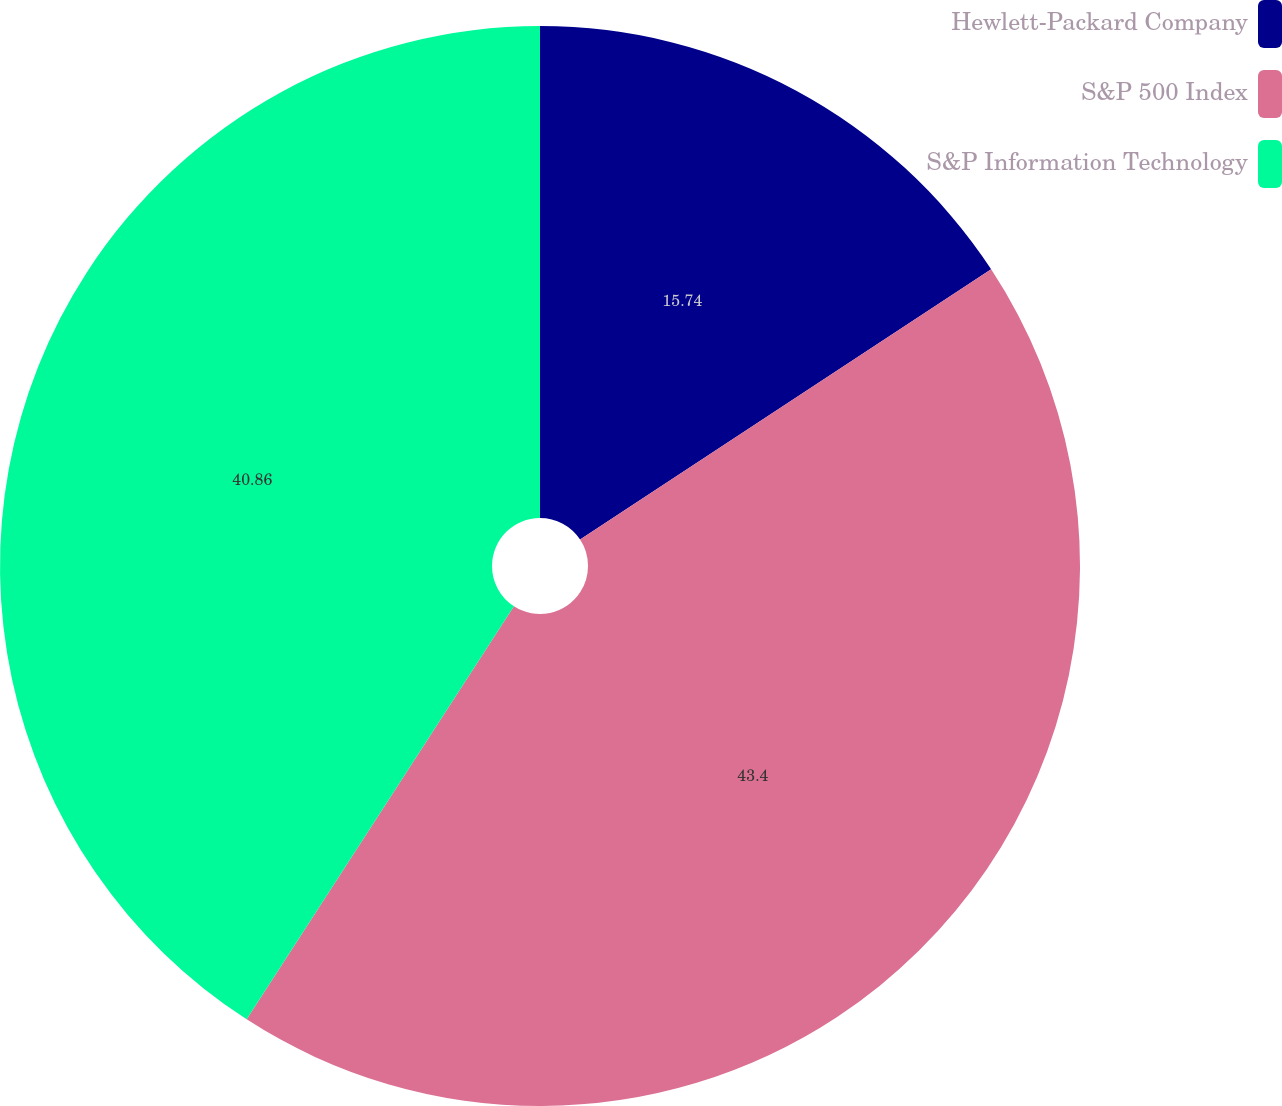<chart> <loc_0><loc_0><loc_500><loc_500><pie_chart><fcel>Hewlett-Packard Company<fcel>S&P 500 Index<fcel>S&P Information Technology<nl><fcel>15.74%<fcel>43.4%<fcel>40.86%<nl></chart> 